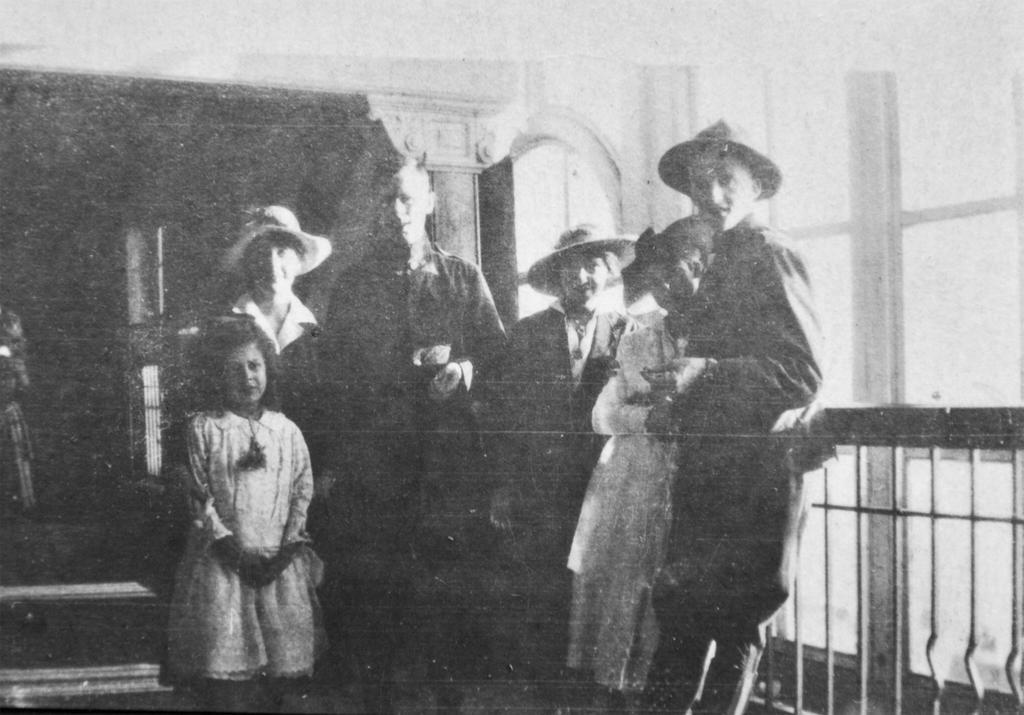Describe this image in one or two sentences. This is an old black and white picture. We can see there is a group of people standing. On the right side of the people there are iron grilles and a window. Behind the people, there is the blurred background. 